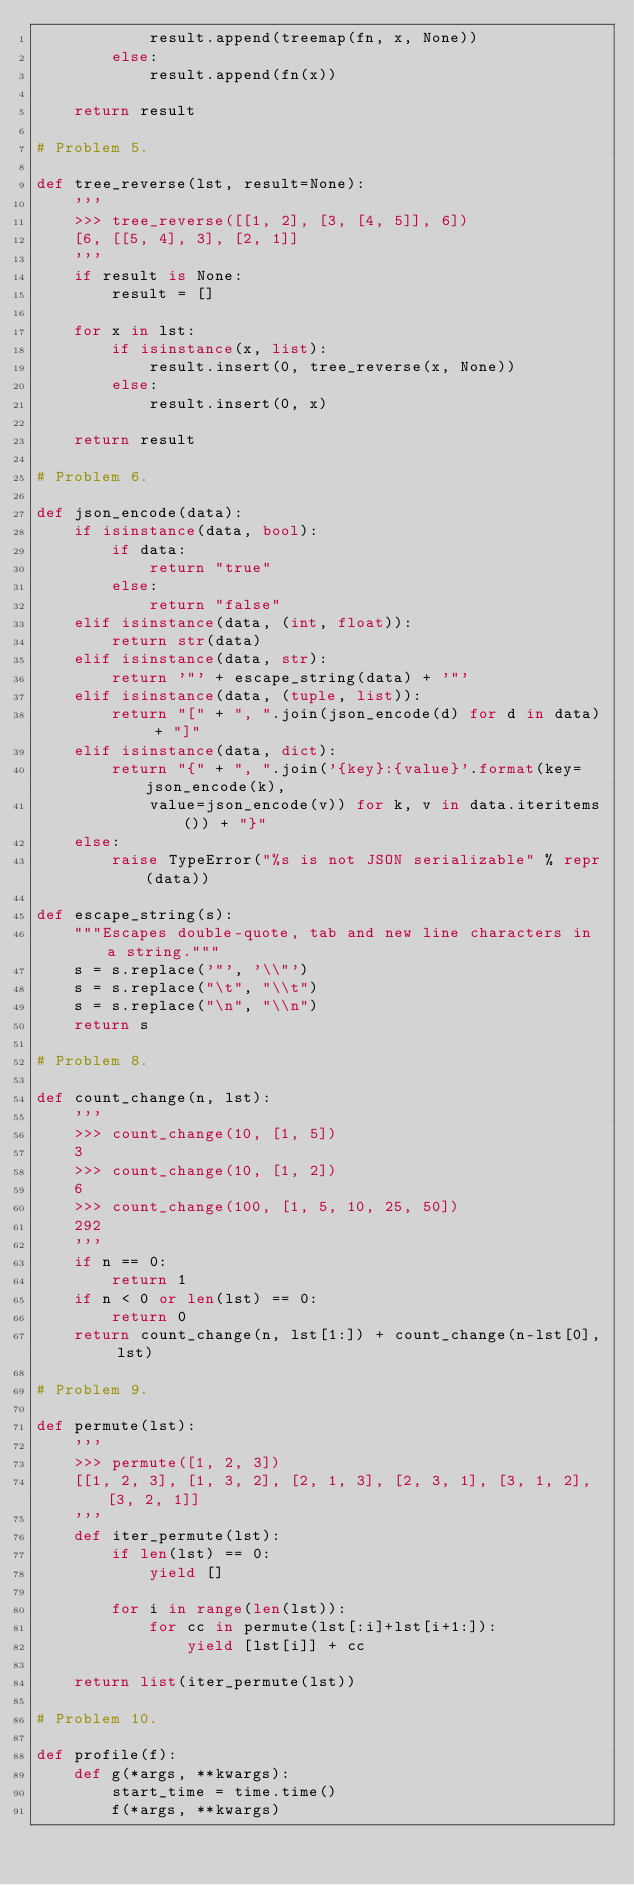Convert code to text. <code><loc_0><loc_0><loc_500><loc_500><_Python_>            result.append(treemap(fn, x, None))
        else:
            result.append(fn(x))

    return result

# Problem 5.

def tree_reverse(lst, result=None):
    '''
    >>> tree_reverse([[1, 2], [3, [4, 5]], 6])
    [6, [[5, 4], 3], [2, 1]]
    '''
    if result is None:
        result = []

    for x in lst:
        if isinstance(x, list):
            result.insert(0, tree_reverse(x, None))
        else:
            result.insert(0, x)

    return result

# Problem 6.

def json_encode(data):
    if isinstance(data, bool):
        if data:
            return "true"
        else:
            return "false"
    elif isinstance(data, (int, float)):
        return str(data)
    elif isinstance(data, str):
        return '"' + escape_string(data) + '"'
    elif isinstance(data, (tuple, list)):
        return "[" + ", ".join(json_encode(d) for d in data) + "]"
    elif isinstance(data, dict):
        return "{" + ", ".join('{key}:{value}'.format(key=json_encode(k),
            value=json_encode(v)) for k, v in data.iteritems()) + "}"
    else:
        raise TypeError("%s is not JSON serializable" % repr(data))

def escape_string(s):
    """Escapes double-quote, tab and new line characters in a string."""
    s = s.replace('"', '\\"')
    s = s.replace("\t", "\\t")
    s = s.replace("\n", "\\n")
    return s

# Problem 8.

def count_change(n, lst):
    '''
    >>> count_change(10, [1, 5])
    3
    >>> count_change(10, [1, 2])
    6
    >>> count_change(100, [1, 5, 10, 25, 50])
    292
    '''
    if n == 0:
        return 1
    if n < 0 or len(lst) == 0:
        return 0
    return count_change(n, lst[1:]) + count_change(n-lst[0], lst)

# Problem 9.

def permute(lst):
    '''
    >>> permute([1, 2, 3])
    [[1, 2, 3], [1, 3, 2], [2, 1, 3], [2, 3, 1], [3, 1, 2], [3, 2, 1]]
    '''
    def iter_permute(lst):
        if len(lst) == 0:
            yield []

        for i in range(len(lst)):
            for cc in permute(lst[:i]+lst[i+1:]):
                yield [lst[i]] + cc

    return list(iter_permute(lst))

# Problem 10.

def profile(f):
    def g(*args, **kwargs):
        start_time = time.time()
        f(*args, **kwargs)</code> 